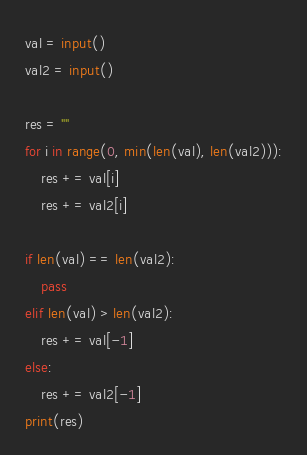Convert code to text. <code><loc_0><loc_0><loc_500><loc_500><_Python_>val = input()
val2 = input()

res = ""
for i in range(0, min(len(val), len(val2))):
    res += val[i]
    res += val2[i]

if len(val) == len(val2):
    pass
elif len(val) > len(val2):
    res += val[-1]
else:
    res += val2[-1]
print(res)</code> 